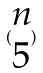Convert formula to latex. <formula><loc_0><loc_0><loc_500><loc_500>( \begin{matrix} n \\ 5 \end{matrix} )</formula> 